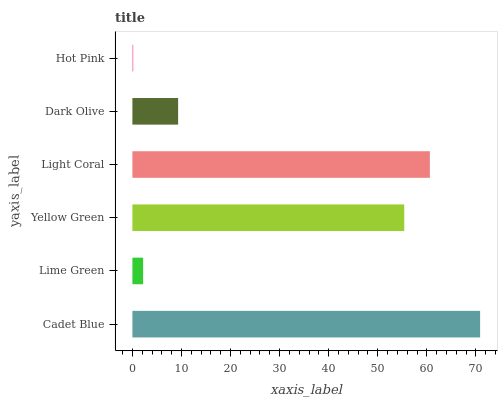Is Hot Pink the minimum?
Answer yes or no. Yes. Is Cadet Blue the maximum?
Answer yes or no. Yes. Is Lime Green the minimum?
Answer yes or no. No. Is Lime Green the maximum?
Answer yes or no. No. Is Cadet Blue greater than Lime Green?
Answer yes or no. Yes. Is Lime Green less than Cadet Blue?
Answer yes or no. Yes. Is Lime Green greater than Cadet Blue?
Answer yes or no. No. Is Cadet Blue less than Lime Green?
Answer yes or no. No. Is Yellow Green the high median?
Answer yes or no. Yes. Is Dark Olive the low median?
Answer yes or no. Yes. Is Lime Green the high median?
Answer yes or no. No. Is Lime Green the low median?
Answer yes or no. No. 